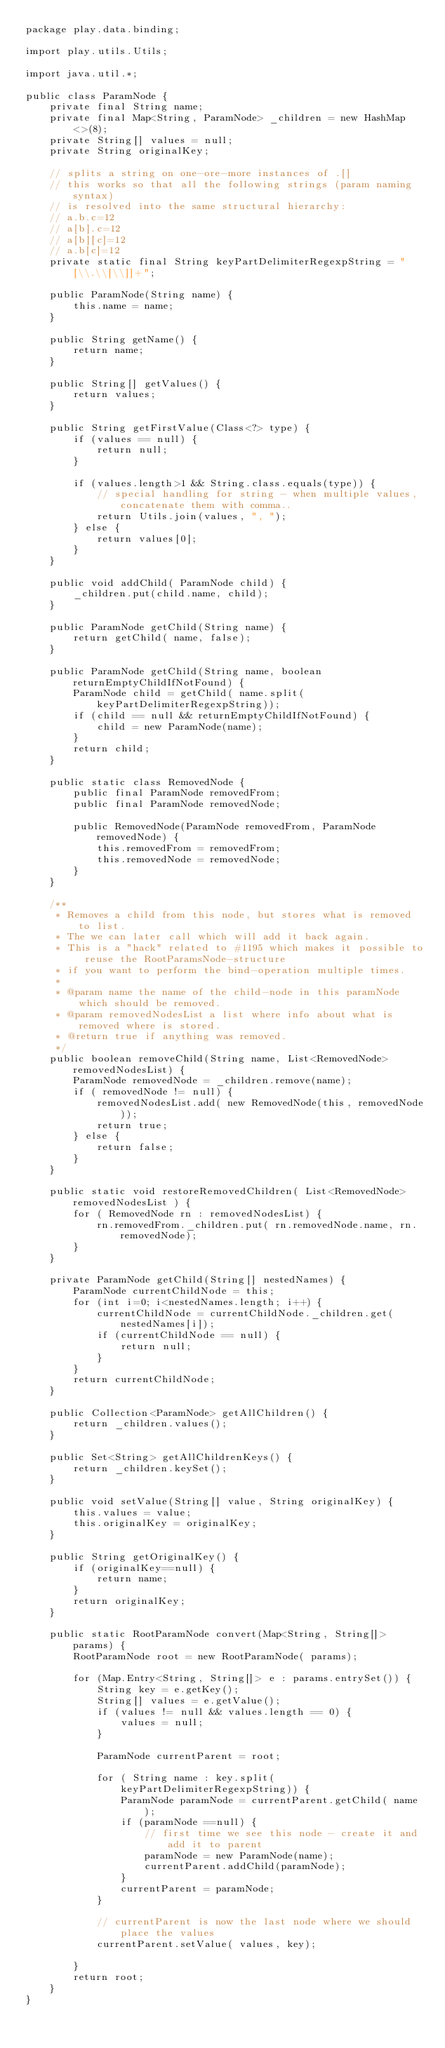Convert code to text. <code><loc_0><loc_0><loc_500><loc_500><_Java_>package play.data.binding;

import play.utils.Utils;

import java.util.*;

public class ParamNode {
    private final String name;
    private final Map<String, ParamNode> _children = new HashMap<>(8);
    private String[] values = null;
    private String originalKey;

    // splits a string on one-ore-more instances of .[]
    // this works so that all the following strings (param naming syntax)
    // is resolved into the same structural hierarchy:
    // a.b.c=12
    // a[b].c=12
    // a[b][c]=12
    // a.b[c]=12
    private static final String keyPartDelimiterRegexpString = "[\\.\\[\\]]+";

    public ParamNode(String name) {
        this.name = name;
    }

    public String getName() {
        return name;
    }

    public String[] getValues() {
        return values;
    }

    public String getFirstValue(Class<?> type) {
        if (values == null) {
            return null;
        }

        if (values.length>1 && String.class.equals(type)) {
            // special handling for string - when multiple values, concatenate them with comma..
            return Utils.join(values, ", ");
        } else {
            return values[0];
        }
    }

    public void addChild( ParamNode child) {
        _children.put(child.name, child);
    }

    public ParamNode getChild(String name) {
        return getChild( name, false);
    }

    public ParamNode getChild(String name, boolean returnEmptyChildIfNotFound) {
        ParamNode child = getChild( name.split(keyPartDelimiterRegexpString));
        if (child == null && returnEmptyChildIfNotFound) {
            child = new ParamNode(name);
        }
        return child;
    }

    public static class RemovedNode {
        public final ParamNode removedFrom;
        public final ParamNode removedNode;

        public RemovedNode(ParamNode removedFrom, ParamNode removedNode) {
            this.removedFrom = removedFrom;
            this.removedNode = removedNode;
        }
    }

    /**
     * Removes a child from this node, but stores what is removed to list.
     * The we can later call which will add it back again.
     * This is a "hack" related to #1195 which makes it possible to reuse the RootParamsNode-structure
     * if you want to perform the bind-operation multiple times.
     *
     * @param name the name of the child-node in this paramNode which should be removed.
     * @param removedNodesList a list where info about what is removed where is stored.
     * @return true if anything was removed.
     */
    public boolean removeChild(String name, List<RemovedNode> removedNodesList) {
        ParamNode removedNode = _children.remove(name);
        if ( removedNode != null) {
            removedNodesList.add( new RemovedNode(this, removedNode));
            return true;
        } else {
            return false;
        }
    }

    public static void restoreRemovedChildren( List<RemovedNode> removedNodesList ) {
        for ( RemovedNode rn : removedNodesList) {
            rn.removedFrom._children.put( rn.removedNode.name, rn.removedNode);
        }
    }

    private ParamNode getChild(String[] nestedNames) {
        ParamNode currentChildNode = this;
        for (int i=0; i<nestedNames.length; i++) {
            currentChildNode = currentChildNode._children.get(nestedNames[i]);
            if (currentChildNode == null) {
                return null;
            }
        }
        return currentChildNode;
    }

    public Collection<ParamNode> getAllChildren() {
        return _children.values();
    }

    public Set<String> getAllChildrenKeys() {
        return _children.keySet();
    }

    public void setValue(String[] value, String originalKey) {
        this.values = value;
        this.originalKey = originalKey;
    }

    public String getOriginalKey() {
        if (originalKey==null) {
            return name;
        }
        return originalKey;
    }

    public static RootParamNode convert(Map<String, String[]> params) {
        RootParamNode root = new RootParamNode( params);

        for (Map.Entry<String, String[]> e : params.entrySet()) {
            String key = e.getKey();
            String[] values = e.getValue();
            if (values != null && values.length == 0) {
                values = null;
            }

            ParamNode currentParent = root;

            for ( String name : key.split(keyPartDelimiterRegexpString)) {
                ParamNode paramNode = currentParent.getChild( name );
                if (paramNode ==null) {
                    // first time we see this node - create it and add it to parent
                    paramNode = new ParamNode(name);
                    currentParent.addChild(paramNode);
                }
                currentParent = paramNode;
            }

            // currentParent is now the last node where we should place the values
            currentParent.setValue( values, key);

        }
        return root;
    }
}</code> 